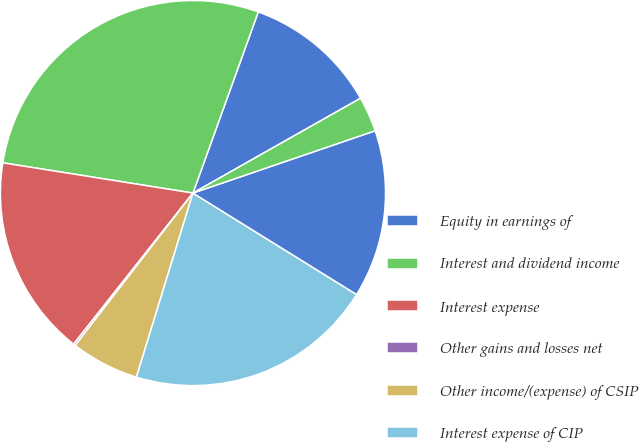Convert chart. <chart><loc_0><loc_0><loc_500><loc_500><pie_chart><fcel>Equity in earnings of<fcel>Interest and dividend income<fcel>Interest expense<fcel>Other gains and losses net<fcel>Other income/(expense) of CSIP<fcel>Interest expense of CIP<fcel>Other gains/(losses) of CIP<fcel>Total other income and<nl><fcel>11.3%<fcel>28.0%<fcel>16.87%<fcel>0.17%<fcel>5.73%<fcel>20.91%<fcel>14.08%<fcel>2.95%<nl></chart> 